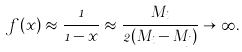<formula> <loc_0><loc_0><loc_500><loc_500>f ( x ) \approx \frac { 1 } { 1 - x } \approx \frac { M _ { i } } { 2 ( M _ { i } - M _ { j } ) } \rightarrow \infty .</formula> 